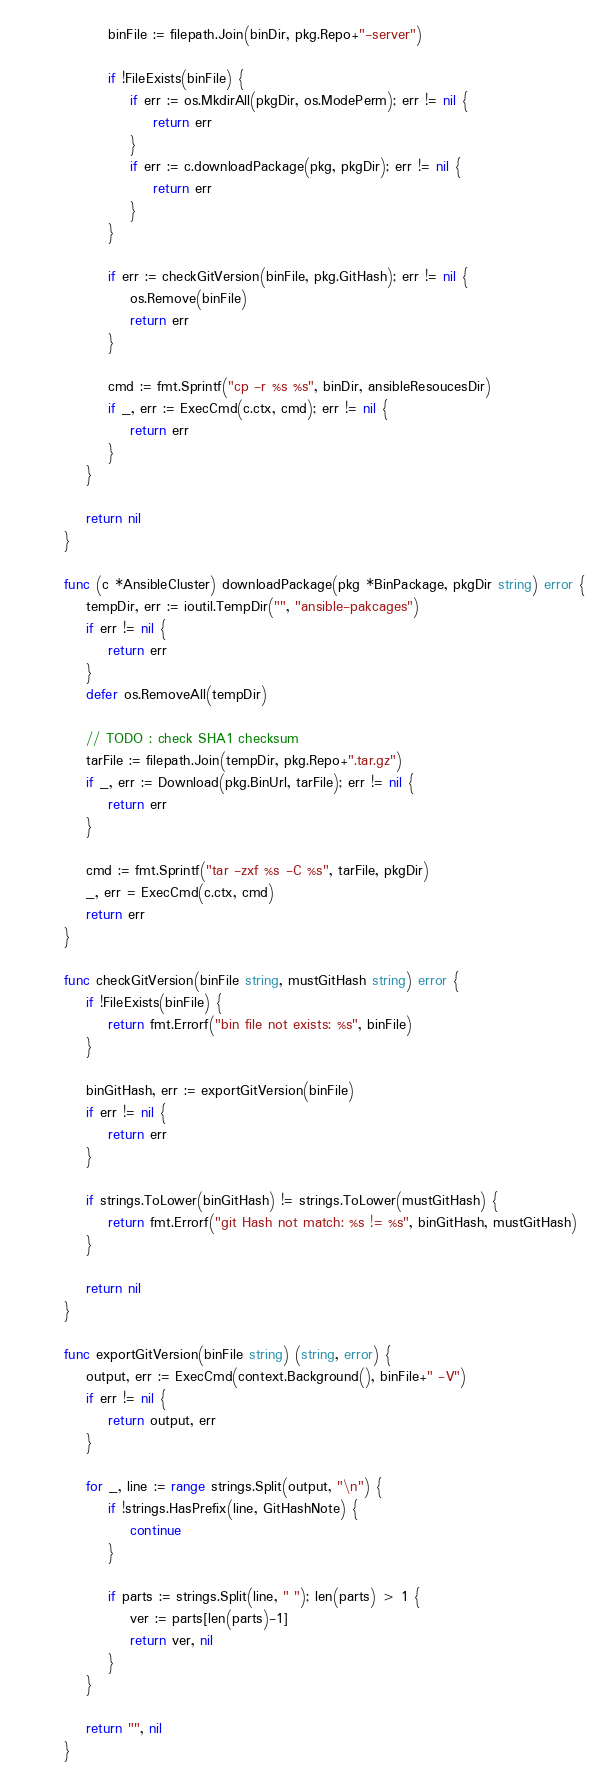<code> <loc_0><loc_0><loc_500><loc_500><_Go_>		binFile := filepath.Join(binDir, pkg.Repo+"-server")

		if !FileExists(binFile) {
			if err := os.MkdirAll(pkgDir, os.ModePerm); err != nil {
				return err
			}
			if err := c.downloadPackage(pkg, pkgDir); err != nil {
				return err
			}
		}

		if err := checkGitVersion(binFile, pkg.GitHash); err != nil {
			os.Remove(binFile)
			return err
		}

		cmd := fmt.Sprintf("cp -r %s %s", binDir, ansibleResoucesDir)
		if _, err := ExecCmd(c.ctx, cmd); err != nil {
			return err
		}
	}

	return nil
}

func (c *AnsibleCluster) downloadPackage(pkg *BinPackage, pkgDir string) error {
	tempDir, err := ioutil.TempDir("", "ansible-pakcages")
	if err != nil {
		return err
	}
	defer os.RemoveAll(tempDir)

	// TODO : check SHA1 checksum
	tarFile := filepath.Join(tempDir, pkg.Repo+".tar.gz")
	if _, err := Download(pkg.BinUrl, tarFile); err != nil {
		return err
	}

	cmd := fmt.Sprintf("tar -zxf %s -C %s", tarFile, pkgDir)
	_, err = ExecCmd(c.ctx, cmd)
	return err
}

func checkGitVersion(binFile string, mustGitHash string) error {
	if !FileExists(binFile) {
		return fmt.Errorf("bin file not exists: %s", binFile)
	}

	binGitHash, err := exportGitVersion(binFile)
	if err != nil {
		return err
	}

	if strings.ToLower(binGitHash) != strings.ToLower(mustGitHash) {
		return fmt.Errorf("git Hash not match: %s != %s", binGitHash, mustGitHash)
	}

	return nil
}

func exportGitVersion(binFile string) (string, error) {
	output, err := ExecCmd(context.Background(), binFile+" -V")
	if err != nil {
		return output, err
	}

	for _, line := range strings.Split(output, "\n") {
		if !strings.HasPrefix(line, GitHashNote) {
			continue
		}

		if parts := strings.Split(line, " "); len(parts) > 1 {
			ver := parts[len(parts)-1]
			return ver, nil
		}
	}

	return "", nil
}
</code> 